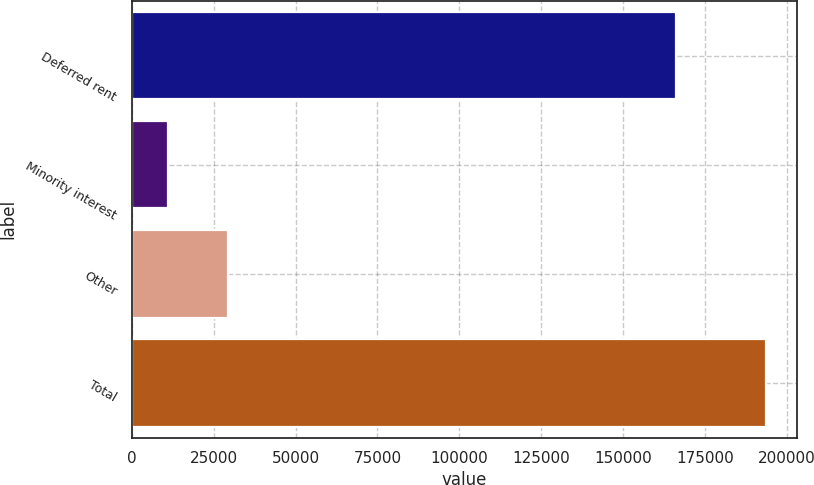Convert chart to OTSL. <chart><loc_0><loc_0><loc_500><loc_500><bar_chart><fcel>Deferred rent<fcel>Minority interest<fcel>Other<fcel>Total<nl><fcel>166182<fcel>11153<fcel>29394.2<fcel>193565<nl></chart> 